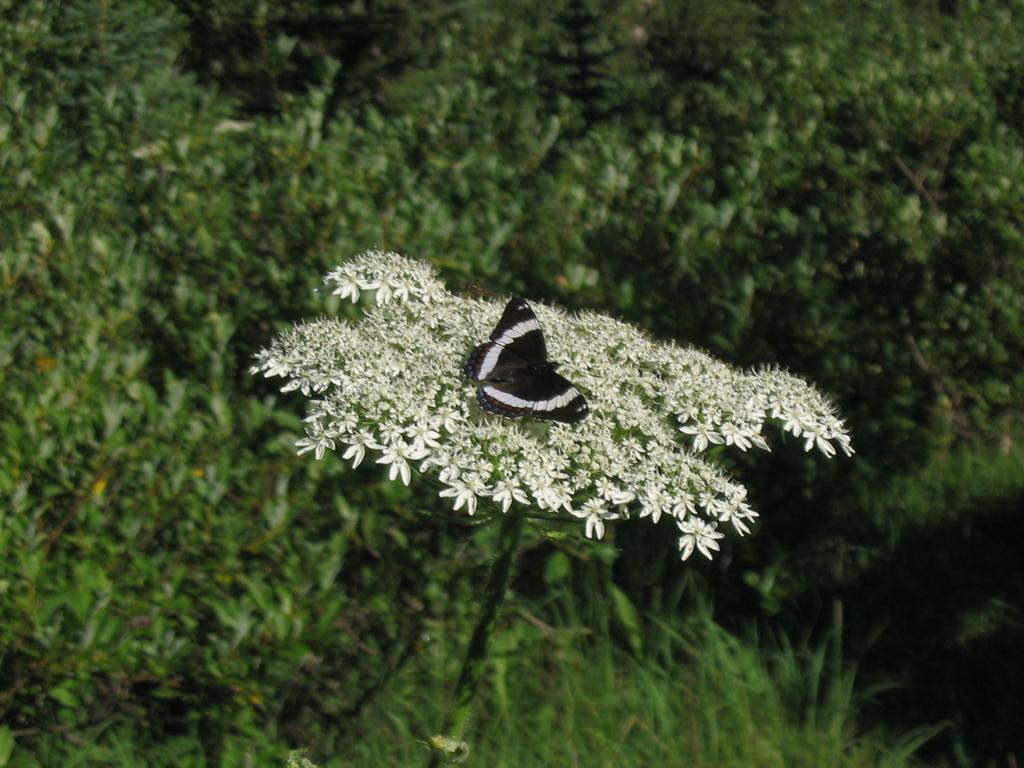Please provide a concise description of this image. This picture seems to be clicked outside. In the center we can see a black color butterfly on the white color flowers. In the background we can see the green grass and the plants. 